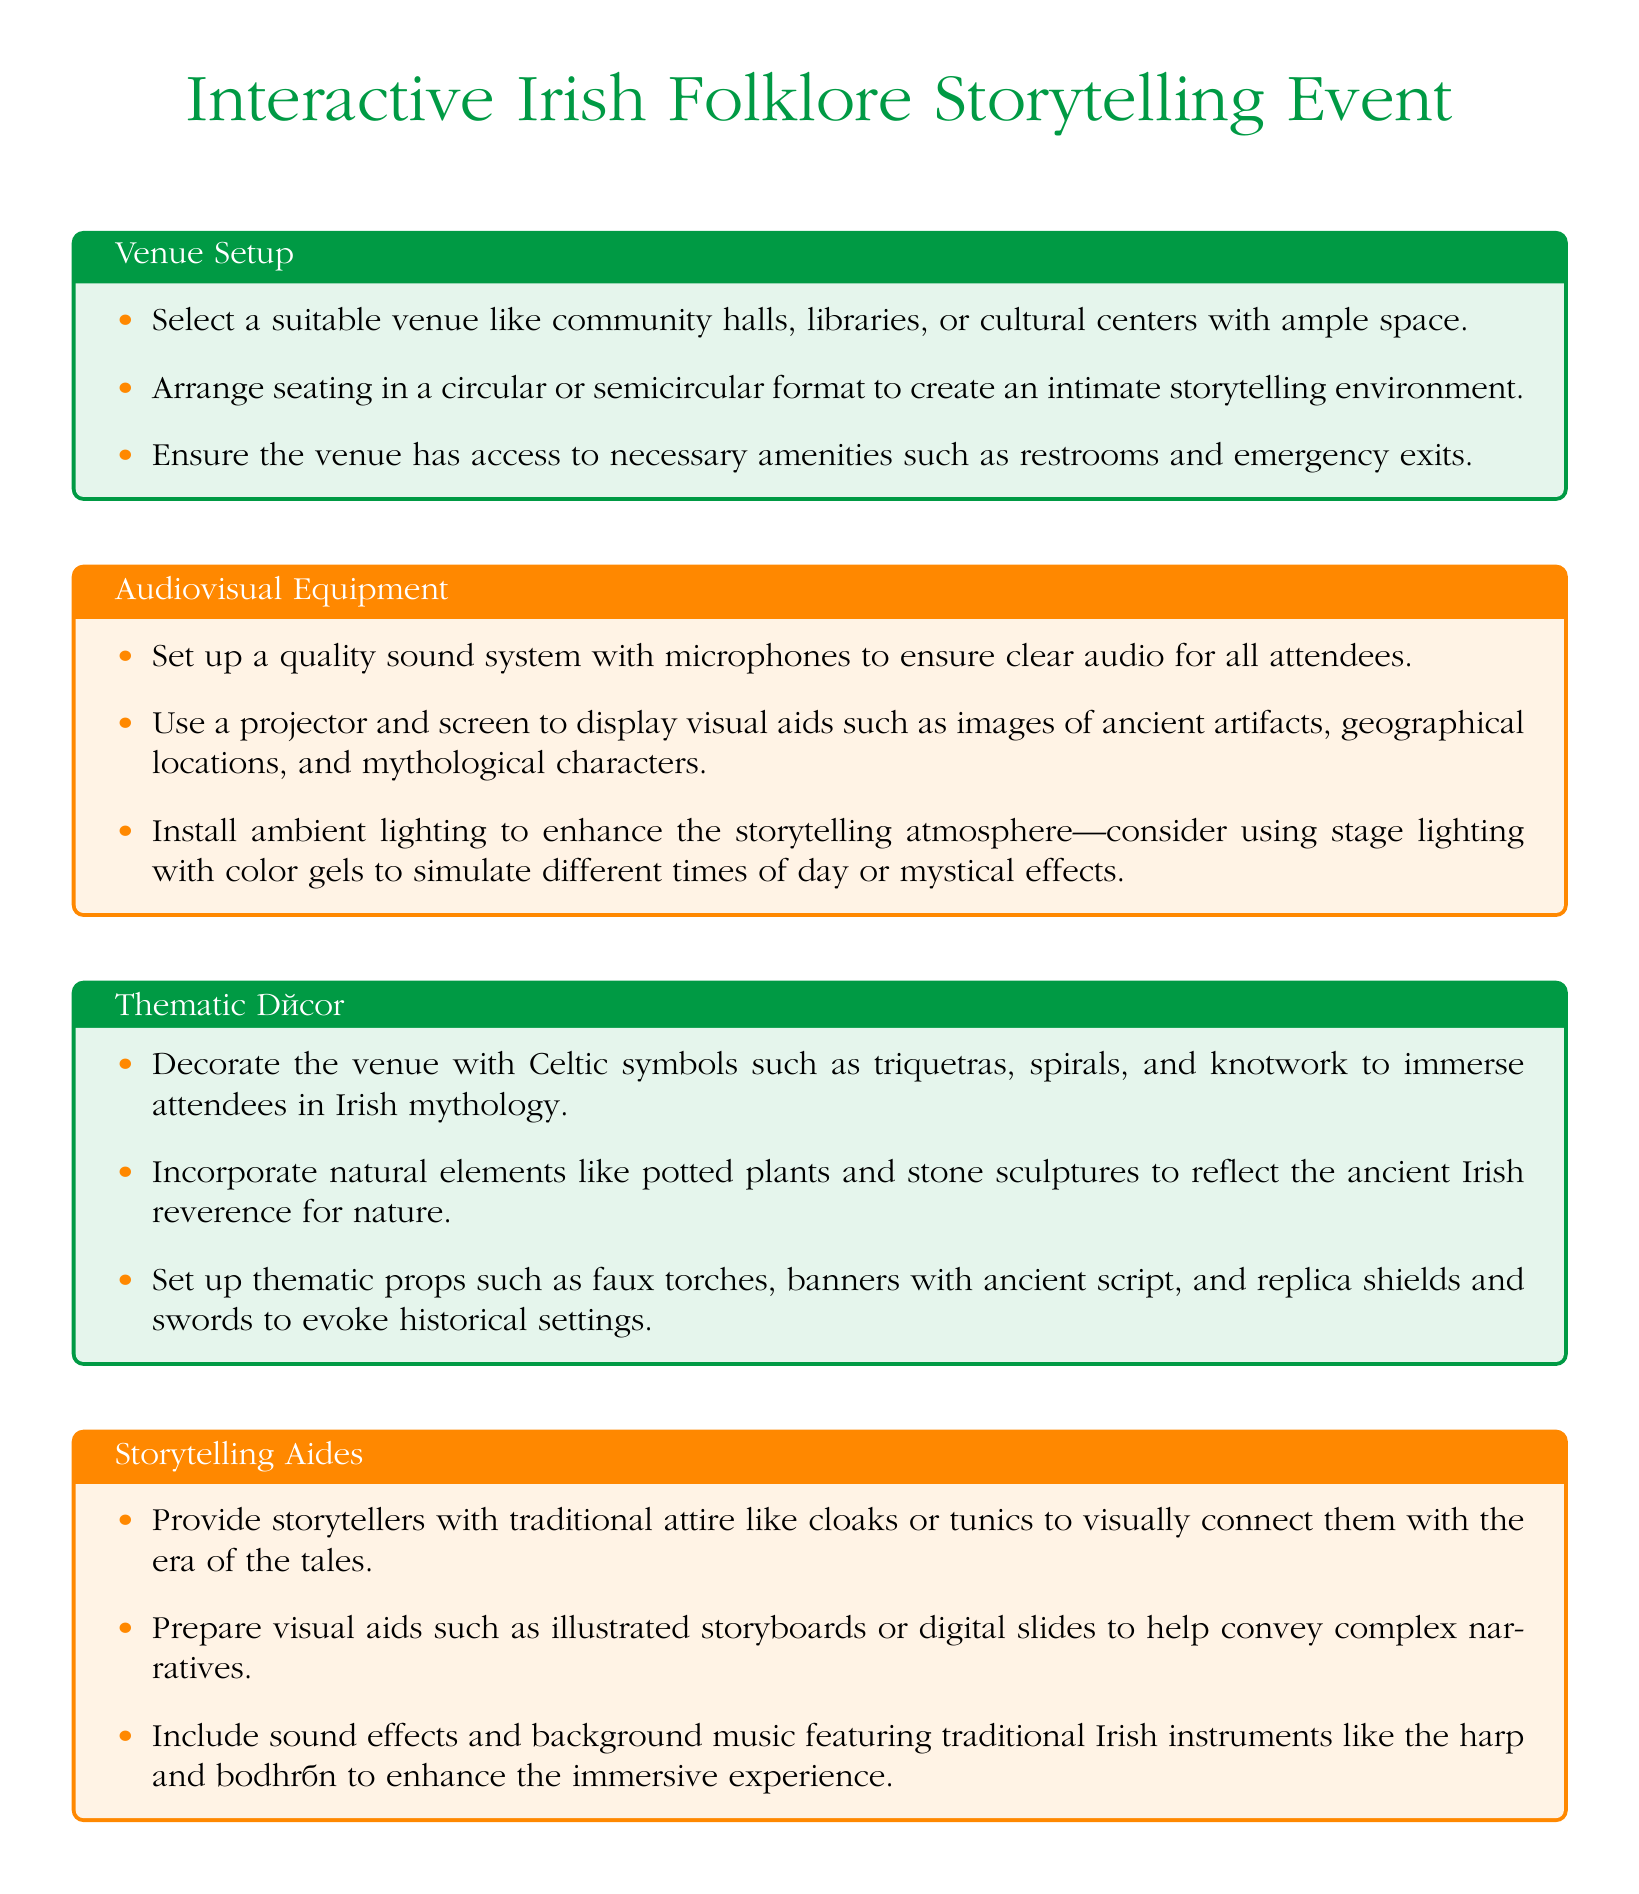what is the color of the title? The title of the document is in the color defined as irish_green.
Answer: irish_green what is one recommended venue type for the event? The document suggests options such as community halls, libraries, or cultural centers for the venue.
Answer: community halls how should seating be arranged in the venue? The seating should be organized in a circular or semicircular format to foster intimacy during storytelling.
Answer: circular or semicircular what type of lighting is suggested for the event? The document recommends ambient lighting, particularly stage lighting with color gels, to enhance the atmosphere.
Answer: ambient lighting what decor elements are suggested to reflect Irish mythology? The document mentions incorporating Celtic symbols, including triquetras, spirals, and knotwork, into the décor.
Answer: Celtic symbols what traditional attire should storytellers wear? Storytellers are advised to wear traditional attire such as cloaks or tunics for visual connection with the era.
Answer: cloaks or tunics which traditional instrument is mentioned for sound effects? The harp is listed as one of the traditional instruments to be used for sound effects during the event.
Answer: harp what is the purpose of using visual aids for storytellers? Visual aids like illustrated storyboards help convey complex narratives to the audience.
Answer: convey complex narratives how many types of thematic decor elements are mentioned? The document lists three thematic décor elements under the section Thematic Decor.
Answer: three 